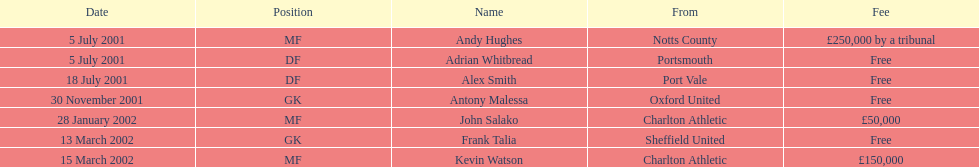Could you parse the entire table as a dict? {'header': ['Date', 'Position', 'Name', 'From', 'Fee'], 'rows': [['5 July 2001', 'MF', 'Andy Hughes', 'Notts County', '£250,000 by a tribunal'], ['5 July 2001', 'DF', 'Adrian Whitbread', 'Portsmouth', 'Free'], ['18 July 2001', 'DF', 'Alex Smith', 'Port Vale', 'Free'], ['30 November 2001', 'GK', 'Antony Malessa', 'Oxford United', 'Free'], ['28 January 2002', 'MF', 'John Salako', 'Charlton Athletic', '£50,000'], ['13 March 2002', 'GK', 'Frank Talia', 'Sheffield United', 'Free'], ['15 March 2002', 'MF', 'Kevin Watson', 'Charlton Athletic', '£150,000']]} Can the chart show a minimum of two different nationalities? Yes. 